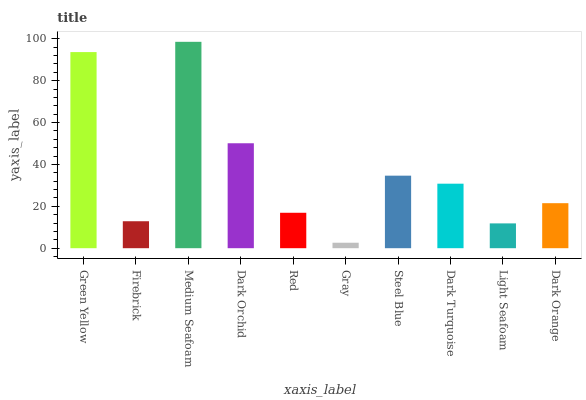Is Gray the minimum?
Answer yes or no. Yes. Is Medium Seafoam the maximum?
Answer yes or no. Yes. Is Firebrick the minimum?
Answer yes or no. No. Is Firebrick the maximum?
Answer yes or no. No. Is Green Yellow greater than Firebrick?
Answer yes or no. Yes. Is Firebrick less than Green Yellow?
Answer yes or no. Yes. Is Firebrick greater than Green Yellow?
Answer yes or no. No. Is Green Yellow less than Firebrick?
Answer yes or no. No. Is Dark Turquoise the high median?
Answer yes or no. Yes. Is Dark Orange the low median?
Answer yes or no. Yes. Is Red the high median?
Answer yes or no. No. Is Steel Blue the low median?
Answer yes or no. No. 